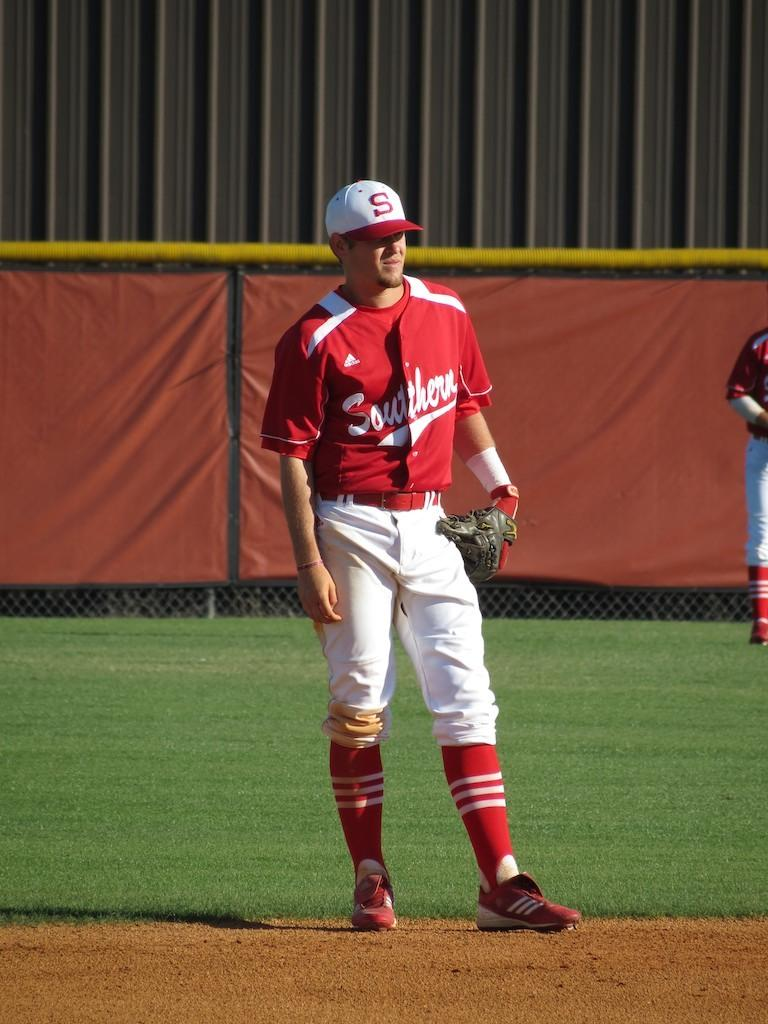<image>
Create a compact narrative representing the image presented. Adidas is the brand of uniform baseball team, Southern, wears. 